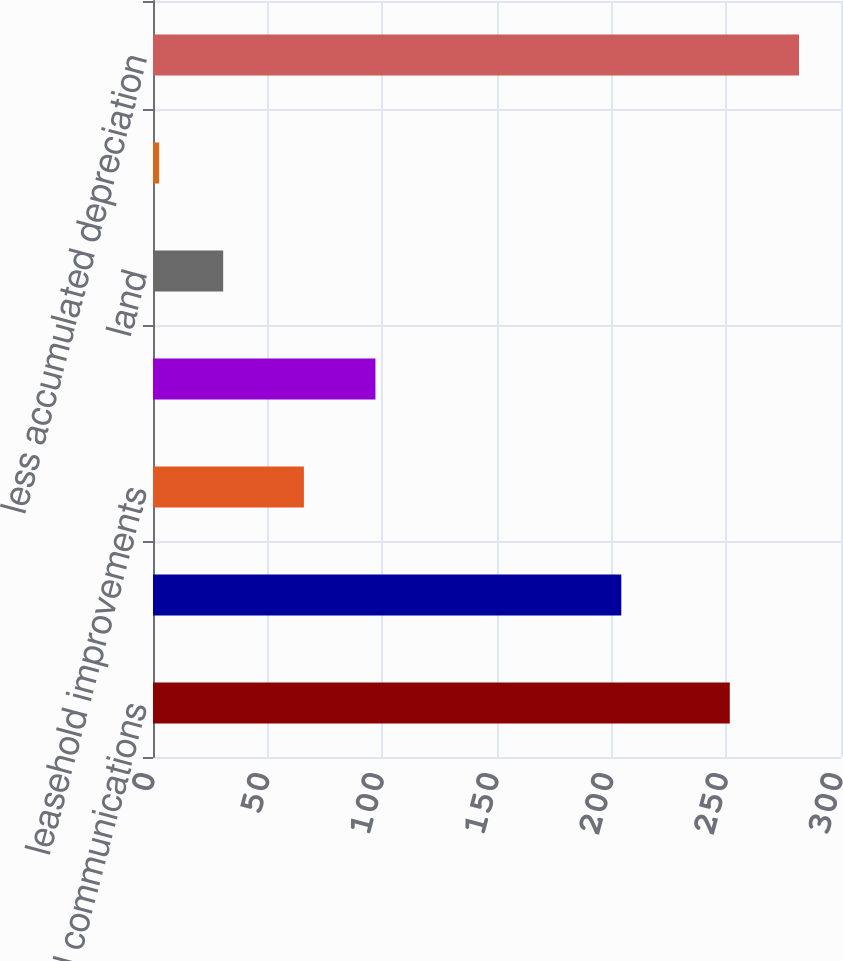<chart> <loc_0><loc_0><loc_500><loc_500><bar_chart><fcel>Computer and communications<fcel>Buildings and improvements<fcel>leasehold improvements<fcel>Furniture and other equipment<fcel>land<fcel>leased land<fcel>less accumulated depreciation<nl><fcel>251.5<fcel>204.2<fcel>65.8<fcel>97<fcel>30.6<fcel>2.7<fcel>281.7<nl></chart> 